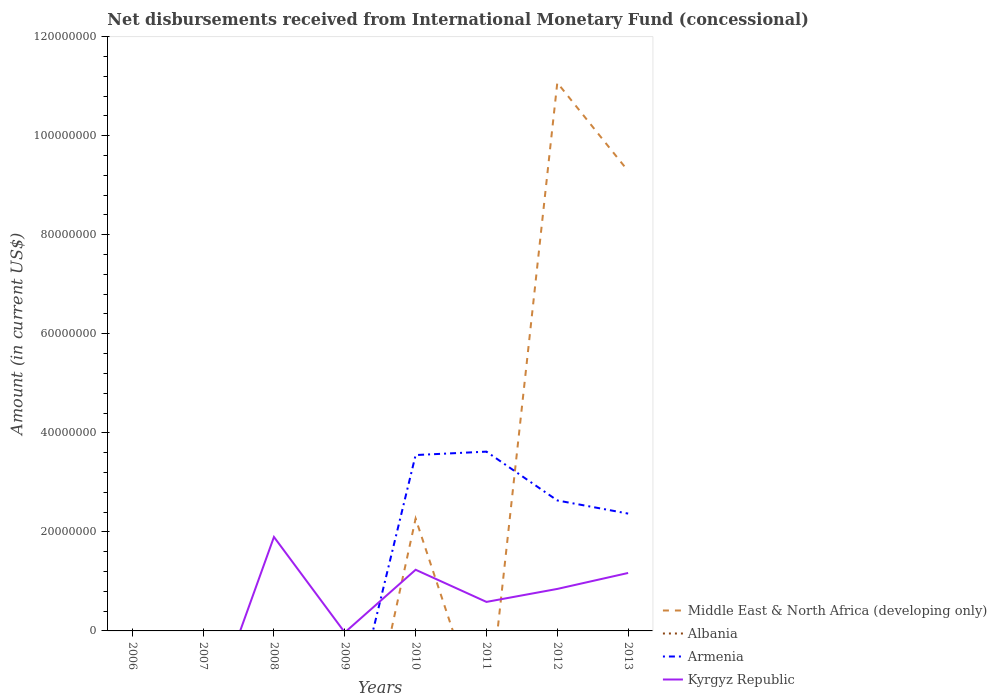How many different coloured lines are there?
Give a very brief answer. 3. Does the line corresponding to Armenia intersect with the line corresponding to Kyrgyz Republic?
Keep it short and to the point. Yes. Across all years, what is the maximum amount of disbursements received from International Monetary Fund in Albania?
Your answer should be very brief. 0. What is the total amount of disbursements received from International Monetary Fund in Armenia in the graph?
Offer a terse response. 9.86e+06. What is the difference between the highest and the second highest amount of disbursements received from International Monetary Fund in Armenia?
Offer a very short reply. 3.62e+07. How many years are there in the graph?
Keep it short and to the point. 8. Are the values on the major ticks of Y-axis written in scientific E-notation?
Provide a succinct answer. No. Does the graph contain any zero values?
Offer a terse response. Yes. Does the graph contain grids?
Offer a terse response. No. What is the title of the graph?
Your answer should be very brief. Net disbursements received from International Monetary Fund (concessional). Does "Indonesia" appear as one of the legend labels in the graph?
Offer a terse response. No. What is the label or title of the X-axis?
Your answer should be compact. Years. What is the label or title of the Y-axis?
Your answer should be compact. Amount (in current US$). What is the Amount (in current US$) in Middle East & North Africa (developing only) in 2006?
Offer a terse response. 0. What is the Amount (in current US$) in Albania in 2006?
Keep it short and to the point. 0. What is the Amount (in current US$) of Armenia in 2006?
Your answer should be very brief. 0. What is the Amount (in current US$) in Kyrgyz Republic in 2006?
Provide a short and direct response. 0. What is the Amount (in current US$) of Middle East & North Africa (developing only) in 2007?
Keep it short and to the point. 0. What is the Amount (in current US$) in Kyrgyz Republic in 2007?
Ensure brevity in your answer.  0. What is the Amount (in current US$) in Kyrgyz Republic in 2008?
Your answer should be compact. 1.90e+07. What is the Amount (in current US$) in Middle East & North Africa (developing only) in 2009?
Provide a succinct answer. 0. What is the Amount (in current US$) in Albania in 2009?
Provide a short and direct response. 0. What is the Amount (in current US$) in Middle East & North Africa (developing only) in 2010?
Give a very brief answer. 2.27e+07. What is the Amount (in current US$) of Albania in 2010?
Offer a terse response. 0. What is the Amount (in current US$) of Armenia in 2010?
Provide a succinct answer. 3.55e+07. What is the Amount (in current US$) of Kyrgyz Republic in 2010?
Your answer should be compact. 1.24e+07. What is the Amount (in current US$) in Albania in 2011?
Keep it short and to the point. 0. What is the Amount (in current US$) in Armenia in 2011?
Keep it short and to the point. 3.62e+07. What is the Amount (in current US$) in Kyrgyz Republic in 2011?
Offer a terse response. 5.86e+06. What is the Amount (in current US$) of Middle East & North Africa (developing only) in 2012?
Provide a succinct answer. 1.11e+08. What is the Amount (in current US$) of Armenia in 2012?
Provide a short and direct response. 2.63e+07. What is the Amount (in current US$) of Kyrgyz Republic in 2012?
Ensure brevity in your answer.  8.48e+06. What is the Amount (in current US$) of Middle East & North Africa (developing only) in 2013?
Your response must be concise. 9.29e+07. What is the Amount (in current US$) in Armenia in 2013?
Offer a very short reply. 2.37e+07. What is the Amount (in current US$) of Kyrgyz Republic in 2013?
Your answer should be very brief. 1.17e+07. Across all years, what is the maximum Amount (in current US$) of Middle East & North Africa (developing only)?
Give a very brief answer. 1.11e+08. Across all years, what is the maximum Amount (in current US$) in Armenia?
Make the answer very short. 3.62e+07. Across all years, what is the maximum Amount (in current US$) in Kyrgyz Republic?
Keep it short and to the point. 1.90e+07. Across all years, what is the minimum Amount (in current US$) in Middle East & North Africa (developing only)?
Ensure brevity in your answer.  0. Across all years, what is the minimum Amount (in current US$) of Armenia?
Provide a succinct answer. 0. What is the total Amount (in current US$) of Middle East & North Africa (developing only) in the graph?
Provide a succinct answer. 2.26e+08. What is the total Amount (in current US$) in Armenia in the graph?
Ensure brevity in your answer.  1.22e+08. What is the total Amount (in current US$) of Kyrgyz Republic in the graph?
Your response must be concise. 5.74e+07. What is the difference between the Amount (in current US$) in Kyrgyz Republic in 2008 and that in 2010?
Provide a short and direct response. 6.62e+06. What is the difference between the Amount (in current US$) in Kyrgyz Republic in 2008 and that in 2011?
Keep it short and to the point. 1.31e+07. What is the difference between the Amount (in current US$) of Kyrgyz Republic in 2008 and that in 2012?
Give a very brief answer. 1.05e+07. What is the difference between the Amount (in current US$) in Kyrgyz Republic in 2008 and that in 2013?
Keep it short and to the point. 7.27e+06. What is the difference between the Amount (in current US$) of Armenia in 2010 and that in 2011?
Your answer should be compact. -6.90e+05. What is the difference between the Amount (in current US$) of Kyrgyz Republic in 2010 and that in 2011?
Give a very brief answer. 6.49e+06. What is the difference between the Amount (in current US$) in Middle East & North Africa (developing only) in 2010 and that in 2012?
Provide a succinct answer. -8.80e+07. What is the difference between the Amount (in current US$) in Armenia in 2010 and that in 2012?
Ensure brevity in your answer.  9.16e+06. What is the difference between the Amount (in current US$) of Kyrgyz Republic in 2010 and that in 2012?
Give a very brief answer. 3.87e+06. What is the difference between the Amount (in current US$) of Middle East & North Africa (developing only) in 2010 and that in 2013?
Your response must be concise. -7.02e+07. What is the difference between the Amount (in current US$) in Armenia in 2010 and that in 2013?
Your answer should be very brief. 1.18e+07. What is the difference between the Amount (in current US$) in Kyrgyz Republic in 2010 and that in 2013?
Provide a short and direct response. 6.48e+05. What is the difference between the Amount (in current US$) of Armenia in 2011 and that in 2012?
Give a very brief answer. 9.86e+06. What is the difference between the Amount (in current US$) of Kyrgyz Republic in 2011 and that in 2012?
Give a very brief answer. -2.62e+06. What is the difference between the Amount (in current US$) of Armenia in 2011 and that in 2013?
Offer a terse response. 1.25e+07. What is the difference between the Amount (in current US$) of Kyrgyz Republic in 2011 and that in 2013?
Your answer should be compact. -5.84e+06. What is the difference between the Amount (in current US$) of Middle East & North Africa (developing only) in 2012 and that in 2013?
Offer a terse response. 1.78e+07. What is the difference between the Amount (in current US$) of Armenia in 2012 and that in 2013?
Keep it short and to the point. 2.65e+06. What is the difference between the Amount (in current US$) of Kyrgyz Republic in 2012 and that in 2013?
Your response must be concise. -3.22e+06. What is the difference between the Amount (in current US$) in Middle East & North Africa (developing only) in 2010 and the Amount (in current US$) in Armenia in 2011?
Your response must be concise. -1.35e+07. What is the difference between the Amount (in current US$) of Middle East & North Africa (developing only) in 2010 and the Amount (in current US$) of Kyrgyz Republic in 2011?
Give a very brief answer. 1.68e+07. What is the difference between the Amount (in current US$) in Armenia in 2010 and the Amount (in current US$) in Kyrgyz Republic in 2011?
Offer a very short reply. 2.97e+07. What is the difference between the Amount (in current US$) of Middle East & North Africa (developing only) in 2010 and the Amount (in current US$) of Armenia in 2012?
Give a very brief answer. -3.67e+06. What is the difference between the Amount (in current US$) in Middle East & North Africa (developing only) in 2010 and the Amount (in current US$) in Kyrgyz Republic in 2012?
Your answer should be very brief. 1.42e+07. What is the difference between the Amount (in current US$) of Armenia in 2010 and the Amount (in current US$) of Kyrgyz Republic in 2012?
Provide a succinct answer. 2.70e+07. What is the difference between the Amount (in current US$) in Middle East & North Africa (developing only) in 2010 and the Amount (in current US$) in Armenia in 2013?
Your answer should be very brief. -1.02e+06. What is the difference between the Amount (in current US$) of Middle East & North Africa (developing only) in 2010 and the Amount (in current US$) of Kyrgyz Republic in 2013?
Provide a succinct answer. 1.10e+07. What is the difference between the Amount (in current US$) in Armenia in 2010 and the Amount (in current US$) in Kyrgyz Republic in 2013?
Ensure brevity in your answer.  2.38e+07. What is the difference between the Amount (in current US$) of Armenia in 2011 and the Amount (in current US$) of Kyrgyz Republic in 2012?
Offer a very short reply. 2.77e+07. What is the difference between the Amount (in current US$) in Armenia in 2011 and the Amount (in current US$) in Kyrgyz Republic in 2013?
Offer a terse response. 2.45e+07. What is the difference between the Amount (in current US$) in Middle East & North Africa (developing only) in 2012 and the Amount (in current US$) in Armenia in 2013?
Provide a short and direct response. 8.70e+07. What is the difference between the Amount (in current US$) of Middle East & North Africa (developing only) in 2012 and the Amount (in current US$) of Kyrgyz Republic in 2013?
Ensure brevity in your answer.  9.90e+07. What is the difference between the Amount (in current US$) in Armenia in 2012 and the Amount (in current US$) in Kyrgyz Republic in 2013?
Ensure brevity in your answer.  1.46e+07. What is the average Amount (in current US$) in Middle East & North Africa (developing only) per year?
Make the answer very short. 2.83e+07. What is the average Amount (in current US$) in Armenia per year?
Give a very brief answer. 1.52e+07. What is the average Amount (in current US$) of Kyrgyz Republic per year?
Offer a terse response. 7.17e+06. In the year 2010, what is the difference between the Amount (in current US$) of Middle East & North Africa (developing only) and Amount (in current US$) of Armenia?
Provide a succinct answer. -1.28e+07. In the year 2010, what is the difference between the Amount (in current US$) of Middle East & North Africa (developing only) and Amount (in current US$) of Kyrgyz Republic?
Give a very brief answer. 1.03e+07. In the year 2010, what is the difference between the Amount (in current US$) in Armenia and Amount (in current US$) in Kyrgyz Republic?
Your answer should be very brief. 2.32e+07. In the year 2011, what is the difference between the Amount (in current US$) of Armenia and Amount (in current US$) of Kyrgyz Republic?
Offer a very short reply. 3.03e+07. In the year 2012, what is the difference between the Amount (in current US$) of Middle East & North Africa (developing only) and Amount (in current US$) of Armenia?
Make the answer very short. 8.43e+07. In the year 2012, what is the difference between the Amount (in current US$) of Middle East & North Africa (developing only) and Amount (in current US$) of Kyrgyz Republic?
Offer a terse response. 1.02e+08. In the year 2012, what is the difference between the Amount (in current US$) in Armenia and Amount (in current US$) in Kyrgyz Republic?
Provide a succinct answer. 1.79e+07. In the year 2013, what is the difference between the Amount (in current US$) in Middle East & North Africa (developing only) and Amount (in current US$) in Armenia?
Your response must be concise. 6.92e+07. In the year 2013, what is the difference between the Amount (in current US$) of Middle East & North Africa (developing only) and Amount (in current US$) of Kyrgyz Republic?
Keep it short and to the point. 8.12e+07. In the year 2013, what is the difference between the Amount (in current US$) in Armenia and Amount (in current US$) in Kyrgyz Republic?
Your response must be concise. 1.20e+07. What is the ratio of the Amount (in current US$) in Kyrgyz Republic in 2008 to that in 2010?
Provide a succinct answer. 1.54. What is the ratio of the Amount (in current US$) of Kyrgyz Republic in 2008 to that in 2011?
Make the answer very short. 3.24. What is the ratio of the Amount (in current US$) of Kyrgyz Republic in 2008 to that in 2012?
Offer a very short reply. 2.24. What is the ratio of the Amount (in current US$) in Kyrgyz Republic in 2008 to that in 2013?
Provide a succinct answer. 1.62. What is the ratio of the Amount (in current US$) in Armenia in 2010 to that in 2011?
Provide a short and direct response. 0.98. What is the ratio of the Amount (in current US$) in Kyrgyz Republic in 2010 to that in 2011?
Your answer should be very brief. 2.11. What is the ratio of the Amount (in current US$) in Middle East & North Africa (developing only) in 2010 to that in 2012?
Make the answer very short. 0.2. What is the ratio of the Amount (in current US$) of Armenia in 2010 to that in 2012?
Give a very brief answer. 1.35. What is the ratio of the Amount (in current US$) in Kyrgyz Republic in 2010 to that in 2012?
Make the answer very short. 1.46. What is the ratio of the Amount (in current US$) of Middle East & North Africa (developing only) in 2010 to that in 2013?
Offer a terse response. 0.24. What is the ratio of the Amount (in current US$) of Armenia in 2010 to that in 2013?
Your response must be concise. 1.5. What is the ratio of the Amount (in current US$) in Kyrgyz Republic in 2010 to that in 2013?
Give a very brief answer. 1.06. What is the ratio of the Amount (in current US$) of Armenia in 2011 to that in 2012?
Offer a very short reply. 1.37. What is the ratio of the Amount (in current US$) of Kyrgyz Republic in 2011 to that in 2012?
Your answer should be very brief. 0.69. What is the ratio of the Amount (in current US$) in Armenia in 2011 to that in 2013?
Provide a succinct answer. 1.53. What is the ratio of the Amount (in current US$) in Kyrgyz Republic in 2011 to that in 2013?
Provide a succinct answer. 0.5. What is the ratio of the Amount (in current US$) of Middle East & North Africa (developing only) in 2012 to that in 2013?
Make the answer very short. 1.19. What is the ratio of the Amount (in current US$) of Armenia in 2012 to that in 2013?
Give a very brief answer. 1.11. What is the ratio of the Amount (in current US$) in Kyrgyz Republic in 2012 to that in 2013?
Offer a terse response. 0.72. What is the difference between the highest and the second highest Amount (in current US$) in Middle East & North Africa (developing only)?
Ensure brevity in your answer.  1.78e+07. What is the difference between the highest and the second highest Amount (in current US$) in Armenia?
Keep it short and to the point. 6.90e+05. What is the difference between the highest and the second highest Amount (in current US$) in Kyrgyz Republic?
Provide a short and direct response. 6.62e+06. What is the difference between the highest and the lowest Amount (in current US$) in Middle East & North Africa (developing only)?
Offer a terse response. 1.11e+08. What is the difference between the highest and the lowest Amount (in current US$) of Armenia?
Make the answer very short. 3.62e+07. What is the difference between the highest and the lowest Amount (in current US$) in Kyrgyz Republic?
Give a very brief answer. 1.90e+07. 